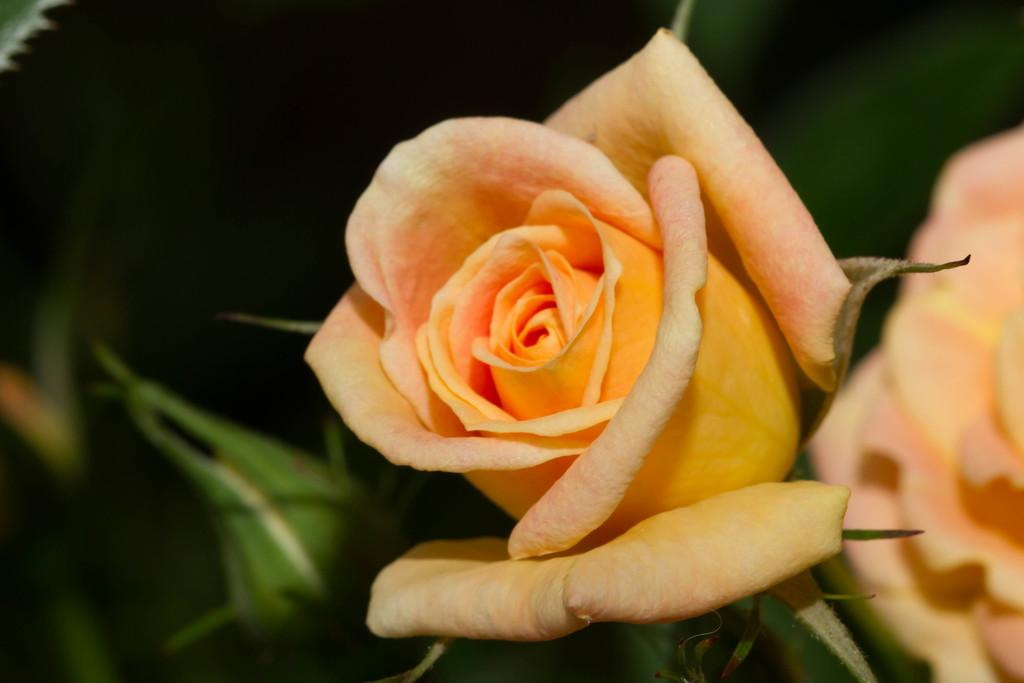What type of flowers are on the right side of the image? There are rose flowers on the right side of the image. What is located on the left side of the image? There is a bud on the left side of the image. What type of pies are displayed in the jar on the left side of the image? There is no jar or pies present in the image; it only features rose flowers and a bud. Can you see a pipe in the image? There is no pipe present in the image. 